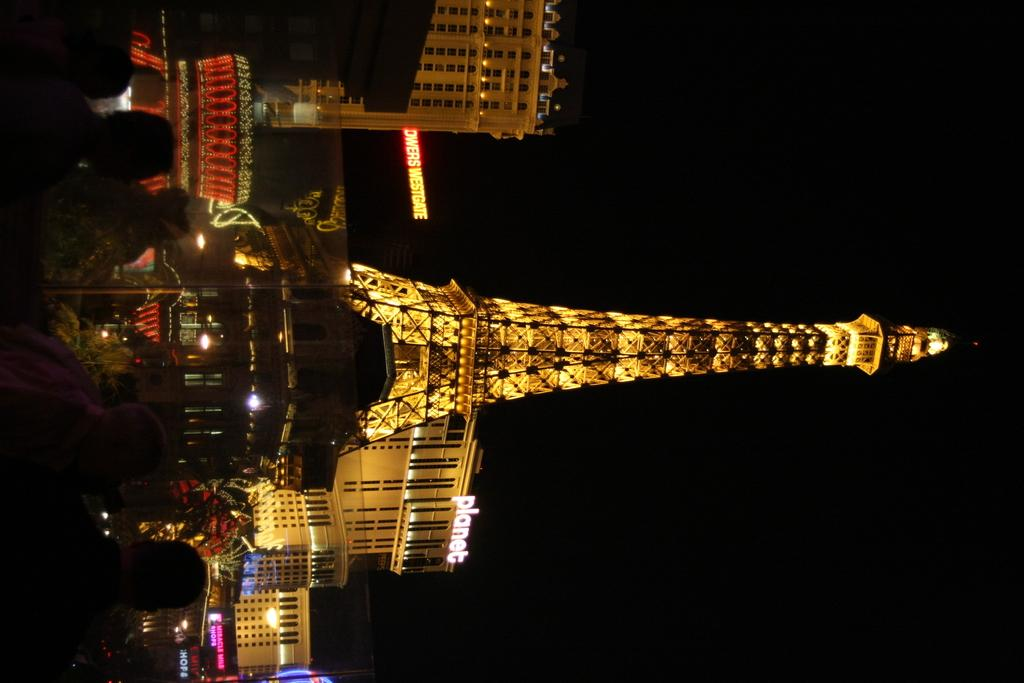Who or what can be seen in the image? There are people in the image. What structure is present in the image? There is a tower in the image. What type of man-made structures are visible in the image? There are buildings in the image. What objects are present in the image that might be used for displaying information or advertisements? There are boards in the image. What is the color of the background in the image? The background of the image is black. What is the purpose of the scarecrow in the image? There is no scarecrow present in the image. What type of instrument is being played by the people in the image? The image does not show any instruments being played by the people. 